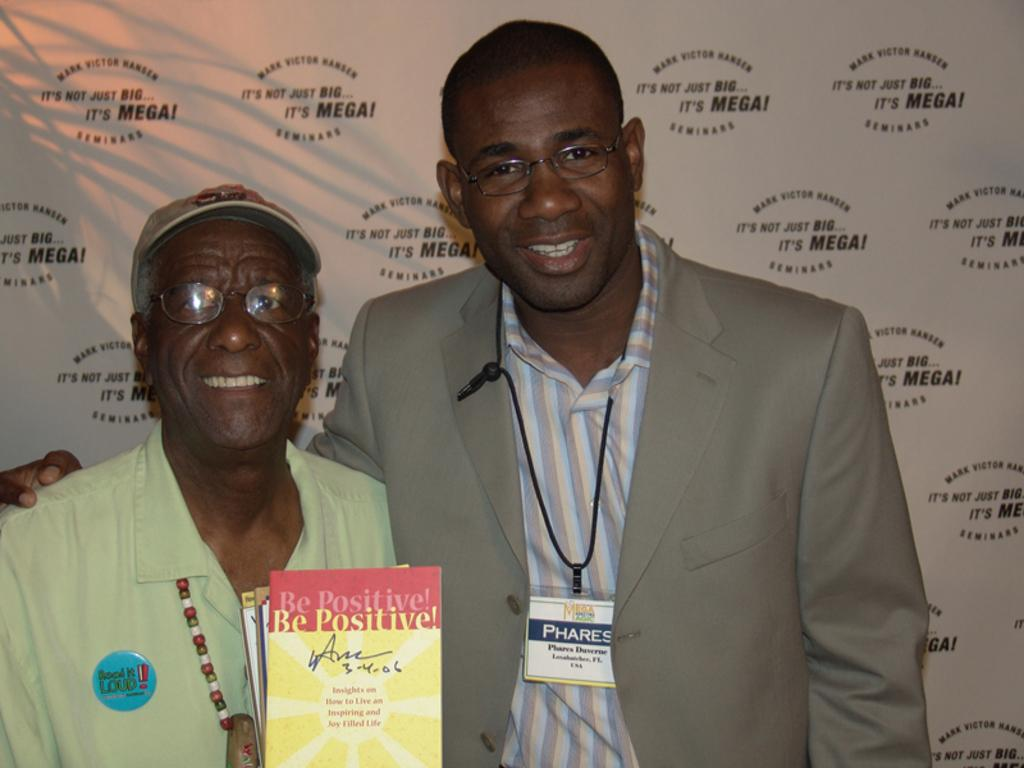How many people are in the image? There are two men in the image. What is one of the men holding? One of the men is holding books. What can be seen in the background of the image? There is a banner with text in the background of the image. What color is the sofa in the image? There is no sofa present in the image. How many fingers does the man with the books have? The number of fingers the man with the books has cannot be determined from the image. 